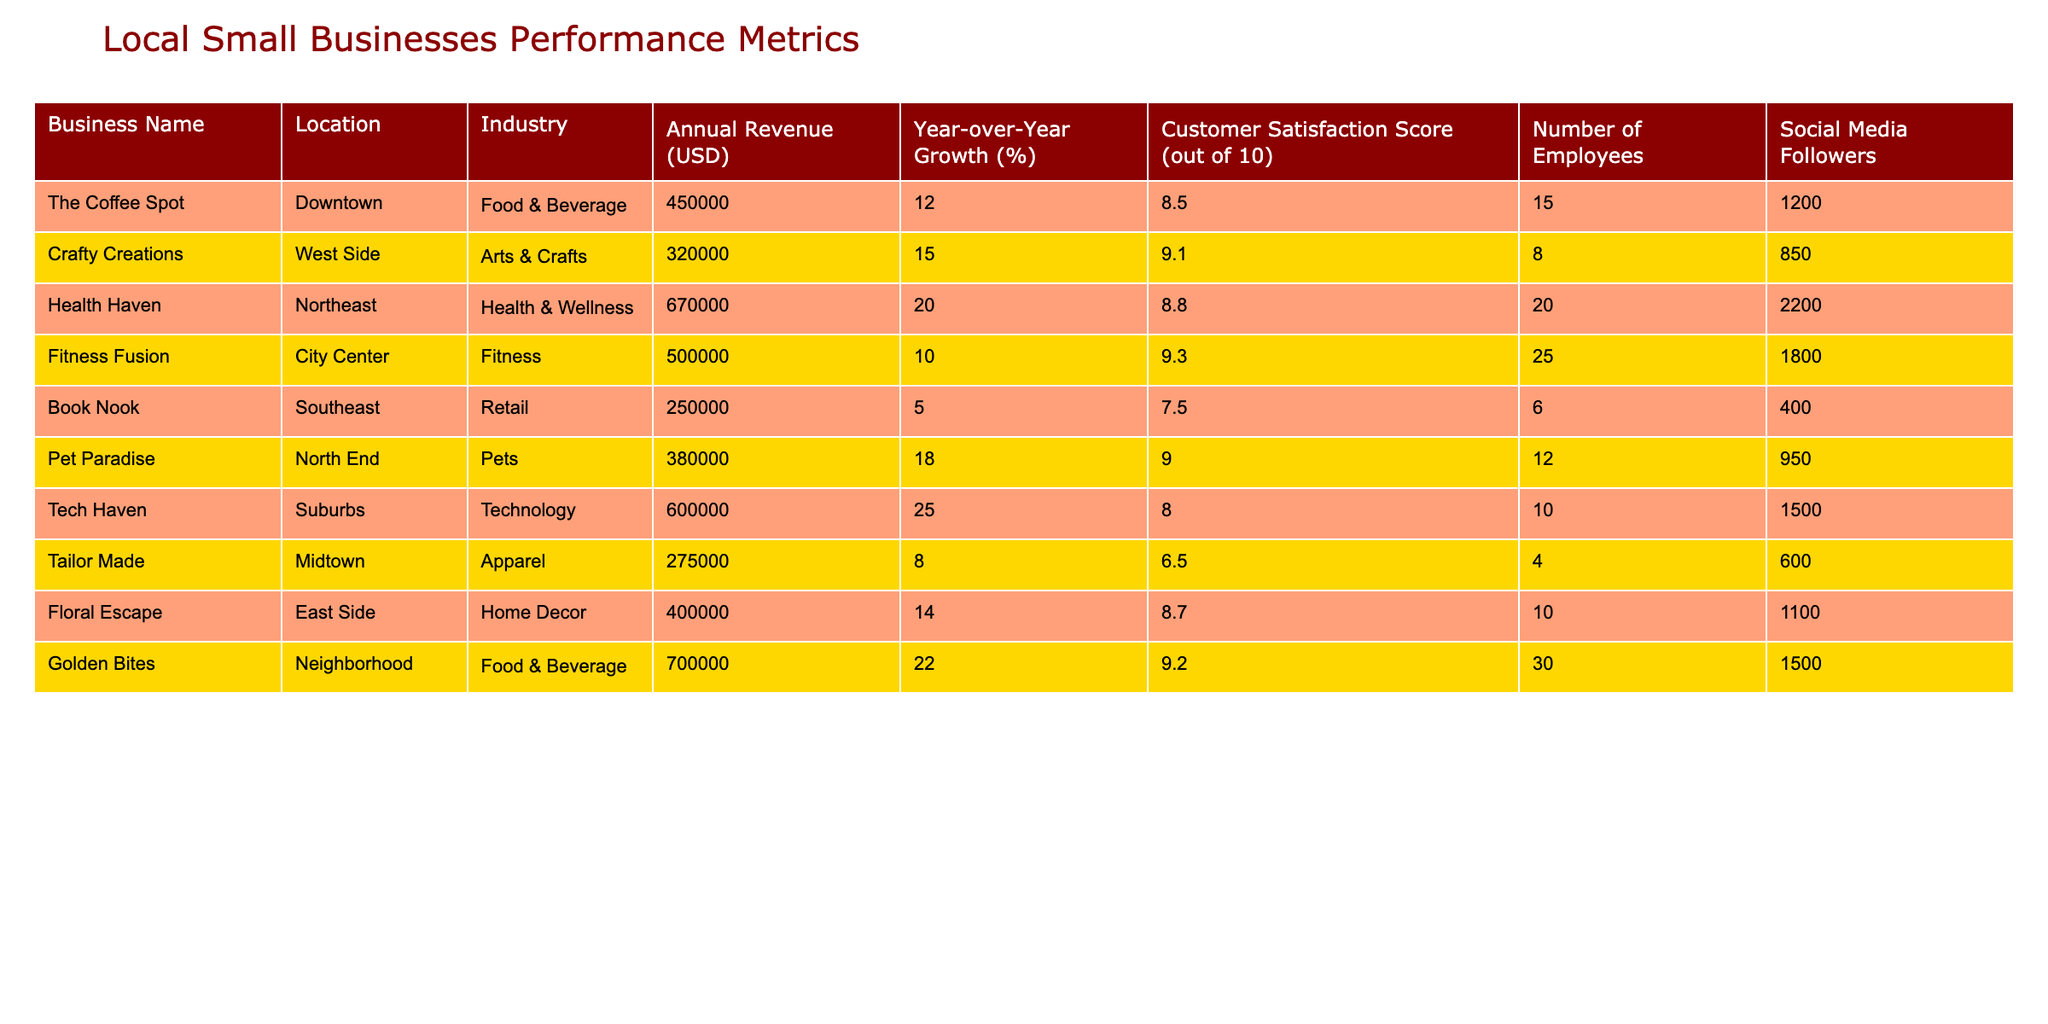What is the annual revenue of Health Haven? The table lists Health Haven's annual revenue, which is clearly stated as 670000 USD.
Answer: 670000 USD Which business has the highest customer satisfaction score? By examining the customer satisfaction scores, we see that Golden Bites has the highest score of 9.2.
Answer: Golden Bites What is the average annual revenue of businesses located in the Food & Beverage industry? The businesses in the Food & Beverage industry are The Coffee Spot (450000), Golden Bites (700000). The average is calculated as (450000 + 700000) / 2 = 575000.
Answer: 575000 USD Does Crafty Creations have a year-over-year growth rate higher than 10%? The year-over-year growth rate for Crafty Creations is 15%, which is higher than 10%, answering yes to the question.
Answer: Yes Which industry has the business with the least number of employees? The table shows Tailor Made in the Apparel industry with the least number of employees, which is 4.
Answer: Apparel What is the total annual revenue of businesses in the Health & Wellness industry and the Fitness industry combined? Health Haven has an annual revenue of 670000, and Fitness Fusion has 500000. The total is 670000 + 500000 = 1170000.
Answer: 1170000 USD Is Tech Haven's growth rate greater than that of Pet Paradise? Tech Haven has a growth rate of 25%, and Pet Paradise has 18%. Comparing both, Tech Haven's growth is greater, confirming the statement is true.
Answer: Yes Which location has the business with the fewest social media followers? Book Nook has the fewest social media followers at 400, making it the lowest in the list when compared to others.
Answer: Southeast What is the median customer satisfaction score among all businesses listed? The scores are 8.5, 9.1, 8.8, 9.3, 7.5, 9.0, 8.0, 6.5, 8.7, and 9.2. When sorted, the median score (middle value) is between 8.7 and 9.0, which averages to 8.85.
Answer: 8.85 